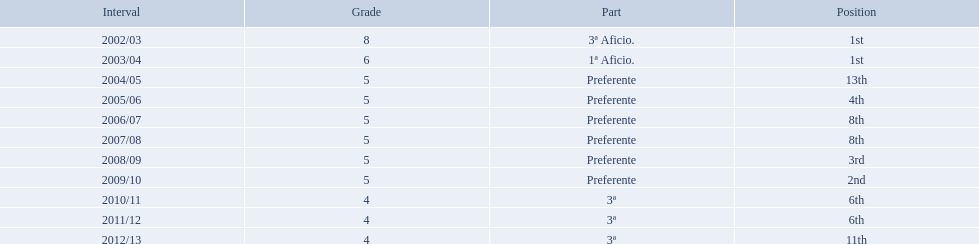Which seasons were played in tier four? 2010/11, 2011/12, 2012/13. Of these seasons, which resulted in 6th place? 2010/11, 2011/12. Which of the remaining happened last? 2011/12. 